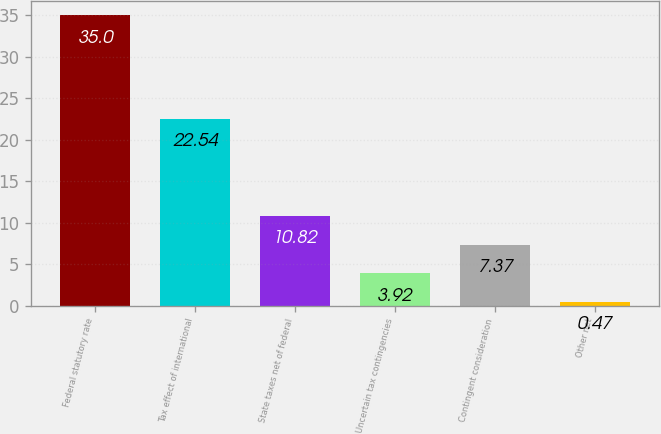Convert chart to OTSL. <chart><loc_0><loc_0><loc_500><loc_500><bar_chart><fcel>Federal statutory rate<fcel>Tax effect of international<fcel>State taxes net of federal<fcel>Uncertain tax contingencies<fcel>Contingent consideration<fcel>Other net<nl><fcel>35<fcel>22.54<fcel>10.82<fcel>3.92<fcel>7.37<fcel>0.47<nl></chart> 